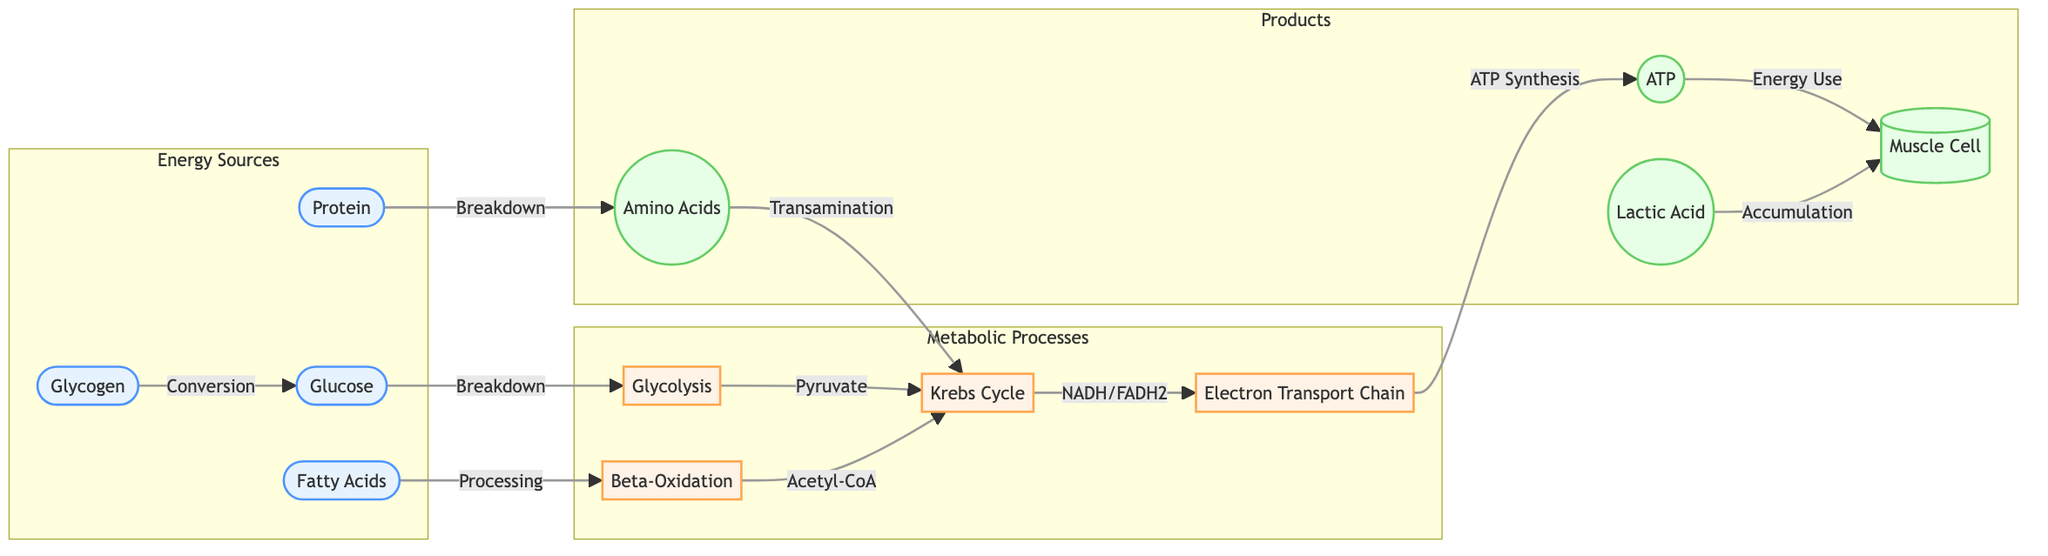What are the four energy sources depicted in the diagram? The diagram shows four nodes under the "Energy Sources" subgraph: Glucose, Glycogen, Fatty Acids, and Protein. These are the primary sources of energy for endurance cycling.
Answer: Glucose, Glycogen, Fatty Acids, Protein Which metabolic process is responsible for ATP synthesis? The flowchart indicates that ATP is synthesized in the Electron Transport Chain (ETC) following the Krebs Cycle, which receives input from NADH and FADH2 produced earlier in the metabolic processes.
Answer: Electron Transport Chain How many metabolic processes are shown in the diagram? The diagram lists four distinct nodes under the "Metabolic Processes" subgraph: Glycolysis, Krebs Cycle, Electron Transport Chain, and Beta-Oxidation. Thus, the total count of processes is four.
Answer: 4 What is the output produced from glycolysis? According to the flowchart, the output of glycolysis is Pyruvate, which then enters the Krebs Cycle. This directly follows from the arrows indicating the flow of metabolites.
Answer: Pyruvate How do fatty acids enter the Krebs Cycle? In the diagram, Fatty Acids undergo Beta-Oxidation, resulting in Acetyl-CoA, which then feeds into the Krebs Cycle. This establishes the connection between Fatty Acids and the Krebs Cycle through Beta-Oxidation.
Answer: Acetyl-CoA What is the relationship between ATP and muscle cells? The flowchart illustrates that ATP is utilized as an energy source for Muscle Cells. This connection is represented by an arrow indicating "Energy Use" from the ATP node to the Muscle Cell node.
Answer: Energy Use What products are generated from protein breakdown? The diagram details that the breakdown of Protein results in Amino Acids, which subsequently enter the Krebs Cycle via a process known as Transamination.
Answer: Amino Acids What accumulates in muscle cells during high intensity exercise? The flowchart depicts that Lactic Acid accumulates in the Muscle Cells, indicating a potential by-product of anaerobic metabolism during periods of intense activity.
Answer: Lactic Acid 